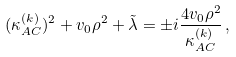Convert formula to latex. <formula><loc_0><loc_0><loc_500><loc_500>( \kappa _ { A C } ^ { ( k ) } ) ^ { 2 } + v _ { 0 } \rho ^ { 2 } + \tilde { \lambda } = \pm i \frac { 4 v _ { 0 } \rho ^ { 2 } } { \kappa _ { A C } ^ { ( k ) } } \, ,</formula> 